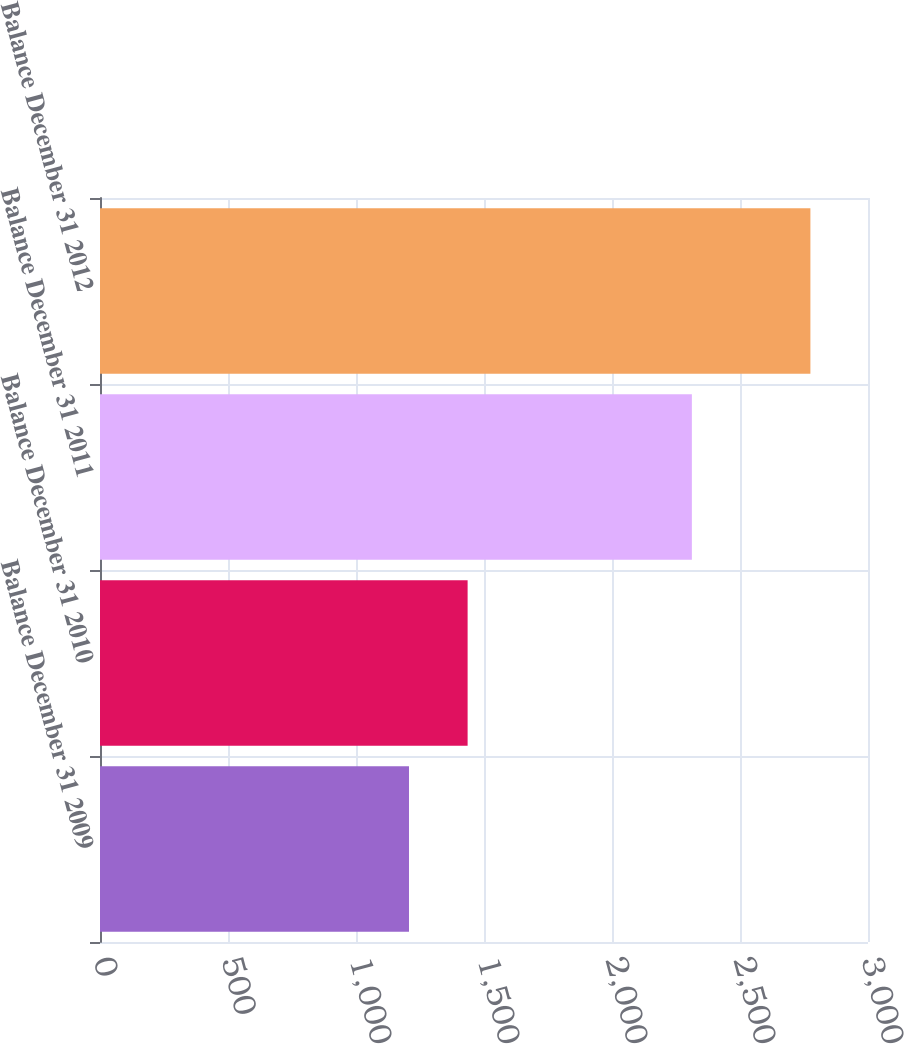<chart> <loc_0><loc_0><loc_500><loc_500><bar_chart><fcel>Balance December 31 2009<fcel>Balance December 31 2010<fcel>Balance December 31 2011<fcel>Balance December 31 2012<nl><fcel>1207<fcel>1436<fcel>2312<fcel>2775<nl></chart> 